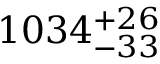Convert formula to latex. <formula><loc_0><loc_0><loc_500><loc_500>1 0 3 4 _ { - 3 3 } ^ { + 2 6 }</formula> 